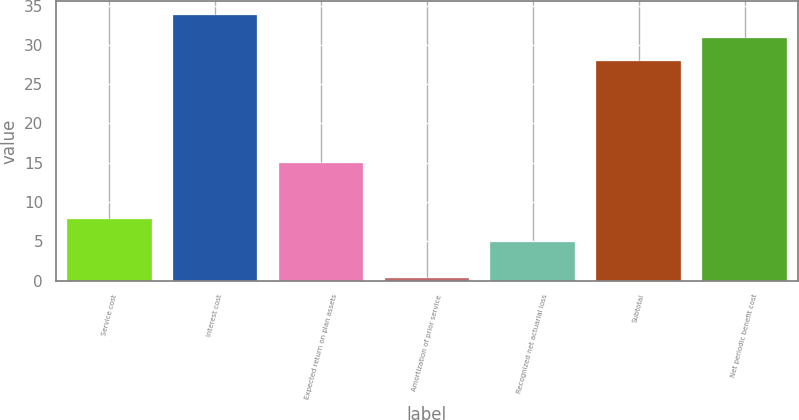Convert chart. <chart><loc_0><loc_0><loc_500><loc_500><bar_chart><fcel>Service cost<fcel>Interest cost<fcel>Expected return on plan assets<fcel>Amortization of prior service<fcel>Recognized net actuarial loss<fcel>Subtotal<fcel>Net periodic benefit cost<nl><fcel>7.82<fcel>33.84<fcel>15<fcel>0.3<fcel>4.9<fcel>28<fcel>30.92<nl></chart> 